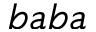Convert formula to latex. <formula><loc_0><loc_0><loc_500><loc_500>b a b a</formula> 